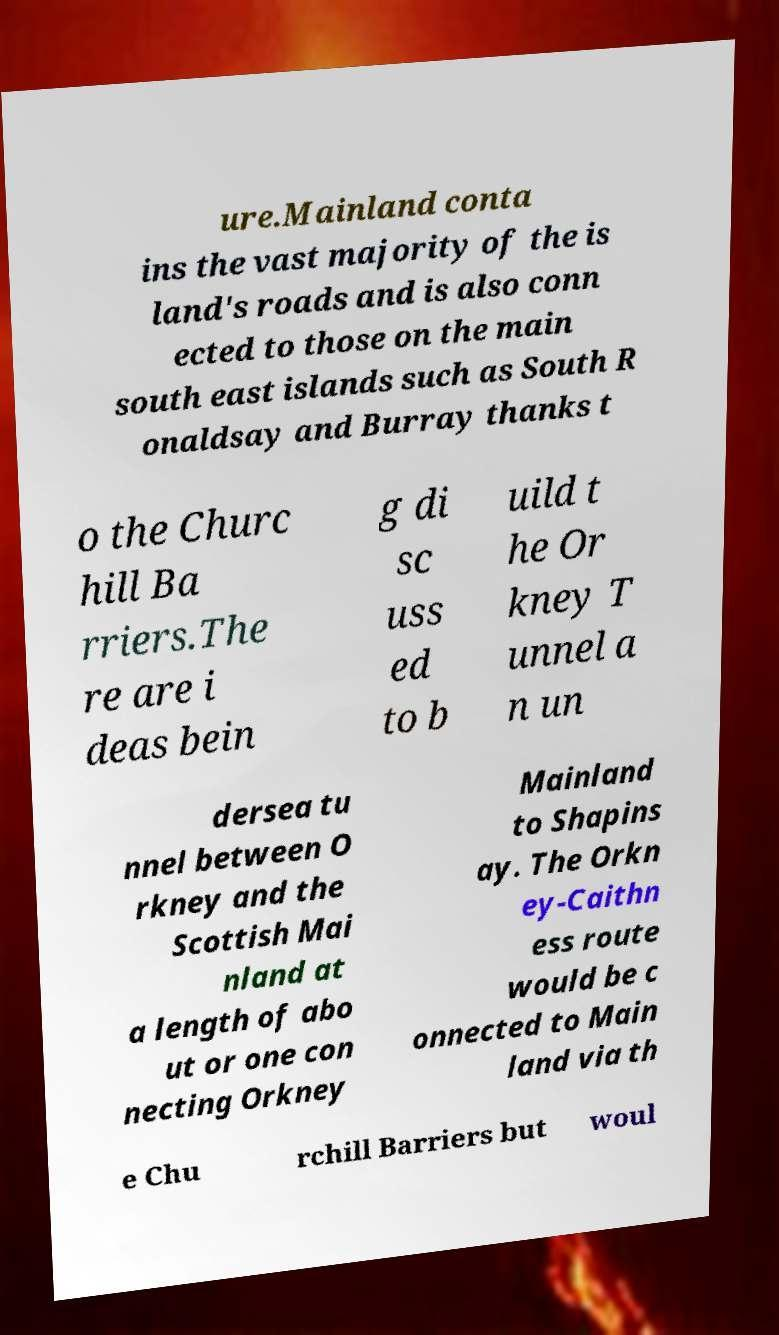Please identify and transcribe the text found in this image. ure.Mainland conta ins the vast majority of the is land's roads and is also conn ected to those on the main south east islands such as South R onaldsay and Burray thanks t o the Churc hill Ba rriers.The re are i deas bein g di sc uss ed to b uild t he Or kney T unnel a n un dersea tu nnel between O rkney and the Scottish Mai nland at a length of abo ut or one con necting Orkney Mainland to Shapins ay. The Orkn ey-Caithn ess route would be c onnected to Main land via th e Chu rchill Barriers but woul 